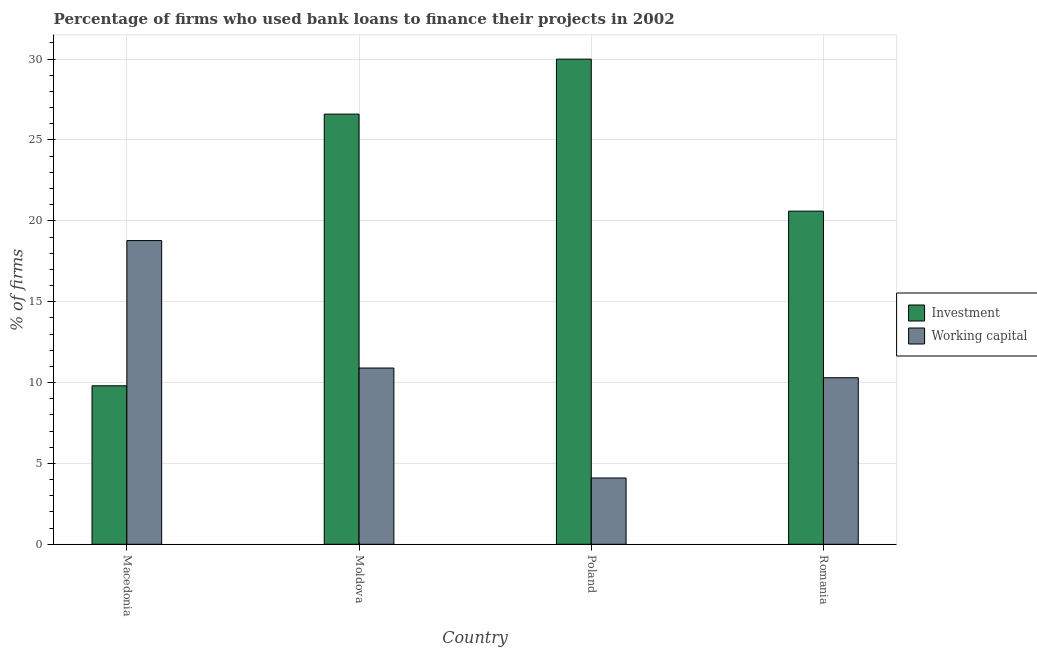How many different coloured bars are there?
Give a very brief answer. 2. Are the number of bars per tick equal to the number of legend labels?
Keep it short and to the point. Yes. How many bars are there on the 1st tick from the right?
Ensure brevity in your answer.  2. What is the label of the 1st group of bars from the left?
Provide a succinct answer. Macedonia. In how many cases, is the number of bars for a given country not equal to the number of legend labels?
Your response must be concise. 0. What is the percentage of firms using banks to finance investment in Poland?
Your answer should be very brief. 30. Across all countries, what is the maximum percentage of firms using banks to finance working capital?
Provide a succinct answer. 18.78. In which country was the percentage of firms using banks to finance investment maximum?
Make the answer very short. Poland. In which country was the percentage of firms using banks to finance working capital minimum?
Your response must be concise. Poland. What is the total percentage of firms using banks to finance working capital in the graph?
Offer a very short reply. 44.08. What is the difference between the percentage of firms using banks to finance working capital in Moldova and that in Poland?
Give a very brief answer. 6.8. What is the difference between the percentage of firms using banks to finance investment in Poland and the percentage of firms using banks to finance working capital in Macedonia?
Provide a succinct answer. 11.22. What is the average percentage of firms using banks to finance investment per country?
Offer a very short reply. 21.75. What is the difference between the percentage of firms using banks to finance investment and percentage of firms using banks to finance working capital in Moldova?
Your answer should be very brief. 15.7. In how many countries, is the percentage of firms using banks to finance investment greater than 30 %?
Ensure brevity in your answer.  0. What is the ratio of the percentage of firms using banks to finance working capital in Macedonia to that in Poland?
Your answer should be compact. 4.58. Is the difference between the percentage of firms using banks to finance working capital in Poland and Romania greater than the difference between the percentage of firms using banks to finance investment in Poland and Romania?
Ensure brevity in your answer.  No. What is the difference between the highest and the second highest percentage of firms using banks to finance working capital?
Give a very brief answer. 7.88. What is the difference between the highest and the lowest percentage of firms using banks to finance working capital?
Ensure brevity in your answer.  14.68. Is the sum of the percentage of firms using banks to finance investment in Macedonia and Moldova greater than the maximum percentage of firms using banks to finance working capital across all countries?
Give a very brief answer. Yes. What does the 1st bar from the left in Macedonia represents?
Provide a succinct answer. Investment. What does the 1st bar from the right in Romania represents?
Keep it short and to the point. Working capital. How many bars are there?
Make the answer very short. 8. Are all the bars in the graph horizontal?
Provide a succinct answer. No. How many countries are there in the graph?
Make the answer very short. 4. What is the difference between two consecutive major ticks on the Y-axis?
Provide a short and direct response. 5. Does the graph contain grids?
Make the answer very short. Yes. How many legend labels are there?
Provide a succinct answer. 2. What is the title of the graph?
Your response must be concise. Percentage of firms who used bank loans to finance their projects in 2002. What is the label or title of the Y-axis?
Offer a terse response. % of firms. What is the % of firms of Investment in Macedonia?
Offer a terse response. 9.8. What is the % of firms in Working capital in Macedonia?
Your response must be concise. 18.78. What is the % of firms in Investment in Moldova?
Provide a short and direct response. 26.6. What is the % of firms of Working capital in Moldova?
Your answer should be very brief. 10.9. What is the % of firms in Investment in Romania?
Offer a very short reply. 20.6. Across all countries, what is the maximum % of firms in Investment?
Give a very brief answer. 30. Across all countries, what is the maximum % of firms in Working capital?
Your response must be concise. 18.78. Across all countries, what is the minimum % of firms in Investment?
Offer a terse response. 9.8. What is the total % of firms of Working capital in the graph?
Ensure brevity in your answer.  44.08. What is the difference between the % of firms of Investment in Macedonia and that in Moldova?
Provide a succinct answer. -16.8. What is the difference between the % of firms in Working capital in Macedonia and that in Moldova?
Your answer should be very brief. 7.88. What is the difference between the % of firms in Investment in Macedonia and that in Poland?
Offer a very short reply. -20.2. What is the difference between the % of firms of Working capital in Macedonia and that in Poland?
Offer a terse response. 14.68. What is the difference between the % of firms in Investment in Macedonia and that in Romania?
Offer a very short reply. -10.8. What is the difference between the % of firms in Working capital in Macedonia and that in Romania?
Keep it short and to the point. 8.48. What is the difference between the % of firms in Investment in Moldova and that in Poland?
Provide a succinct answer. -3.4. What is the difference between the % of firms in Working capital in Moldova and that in Poland?
Provide a short and direct response. 6.8. What is the difference between the % of firms of Working capital in Moldova and that in Romania?
Give a very brief answer. 0.6. What is the difference between the % of firms of Investment in Macedonia and the % of firms of Working capital in Romania?
Your answer should be very brief. -0.5. What is the difference between the % of firms of Investment in Moldova and the % of firms of Working capital in Poland?
Your answer should be compact. 22.5. What is the average % of firms of Investment per country?
Keep it short and to the point. 21.75. What is the average % of firms of Working capital per country?
Provide a short and direct response. 11.02. What is the difference between the % of firms in Investment and % of firms in Working capital in Macedonia?
Offer a terse response. -8.98. What is the difference between the % of firms in Investment and % of firms in Working capital in Poland?
Provide a succinct answer. 25.9. What is the ratio of the % of firms of Investment in Macedonia to that in Moldova?
Offer a terse response. 0.37. What is the ratio of the % of firms of Working capital in Macedonia to that in Moldova?
Offer a terse response. 1.72. What is the ratio of the % of firms in Investment in Macedonia to that in Poland?
Your response must be concise. 0.33. What is the ratio of the % of firms of Working capital in Macedonia to that in Poland?
Provide a short and direct response. 4.58. What is the ratio of the % of firms of Investment in Macedonia to that in Romania?
Your answer should be compact. 0.48. What is the ratio of the % of firms in Working capital in Macedonia to that in Romania?
Provide a succinct answer. 1.82. What is the ratio of the % of firms of Investment in Moldova to that in Poland?
Keep it short and to the point. 0.89. What is the ratio of the % of firms of Working capital in Moldova to that in Poland?
Keep it short and to the point. 2.66. What is the ratio of the % of firms of Investment in Moldova to that in Romania?
Ensure brevity in your answer.  1.29. What is the ratio of the % of firms in Working capital in Moldova to that in Romania?
Make the answer very short. 1.06. What is the ratio of the % of firms of Investment in Poland to that in Romania?
Provide a succinct answer. 1.46. What is the ratio of the % of firms in Working capital in Poland to that in Romania?
Your response must be concise. 0.4. What is the difference between the highest and the second highest % of firms of Working capital?
Your answer should be compact. 7.88. What is the difference between the highest and the lowest % of firms of Investment?
Ensure brevity in your answer.  20.2. What is the difference between the highest and the lowest % of firms of Working capital?
Ensure brevity in your answer.  14.68. 